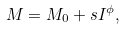<formula> <loc_0><loc_0><loc_500><loc_500>M = M _ { 0 } + s I ^ { \phi } ,</formula> 